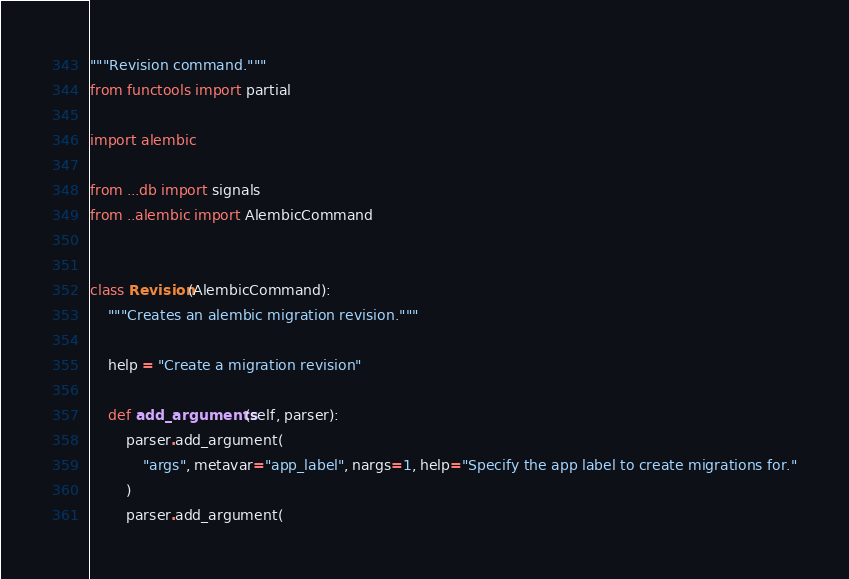<code> <loc_0><loc_0><loc_500><loc_500><_Python_>"""Revision command."""
from functools import partial

import alembic

from ...db import signals
from ..alembic import AlembicCommand


class Revision(AlembicCommand):
    """Creates an alembic migration revision."""

    help = "Create a migration revision"

    def add_arguments(self, parser):
        parser.add_argument(
            "args", metavar="app_label", nargs=1, help="Specify the app label to create migrations for."
        )
        parser.add_argument(</code> 